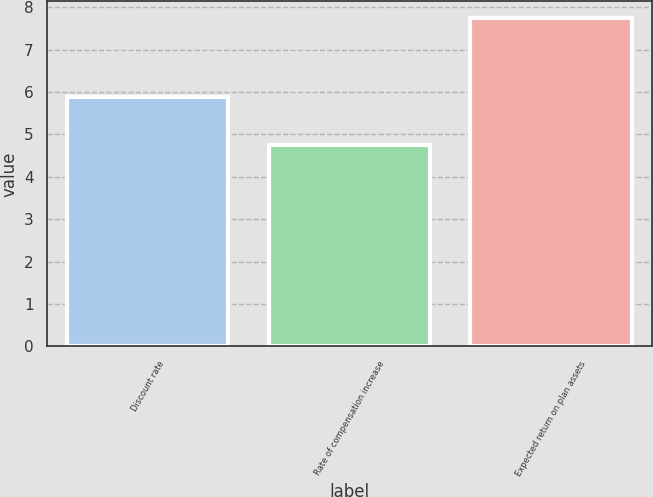Convert chart to OTSL. <chart><loc_0><loc_0><loc_500><loc_500><bar_chart><fcel>Discount rate<fcel>Rate of compensation increase<fcel>Expected return on plan assets<nl><fcel>5.88<fcel>4.75<fcel>7.75<nl></chart> 